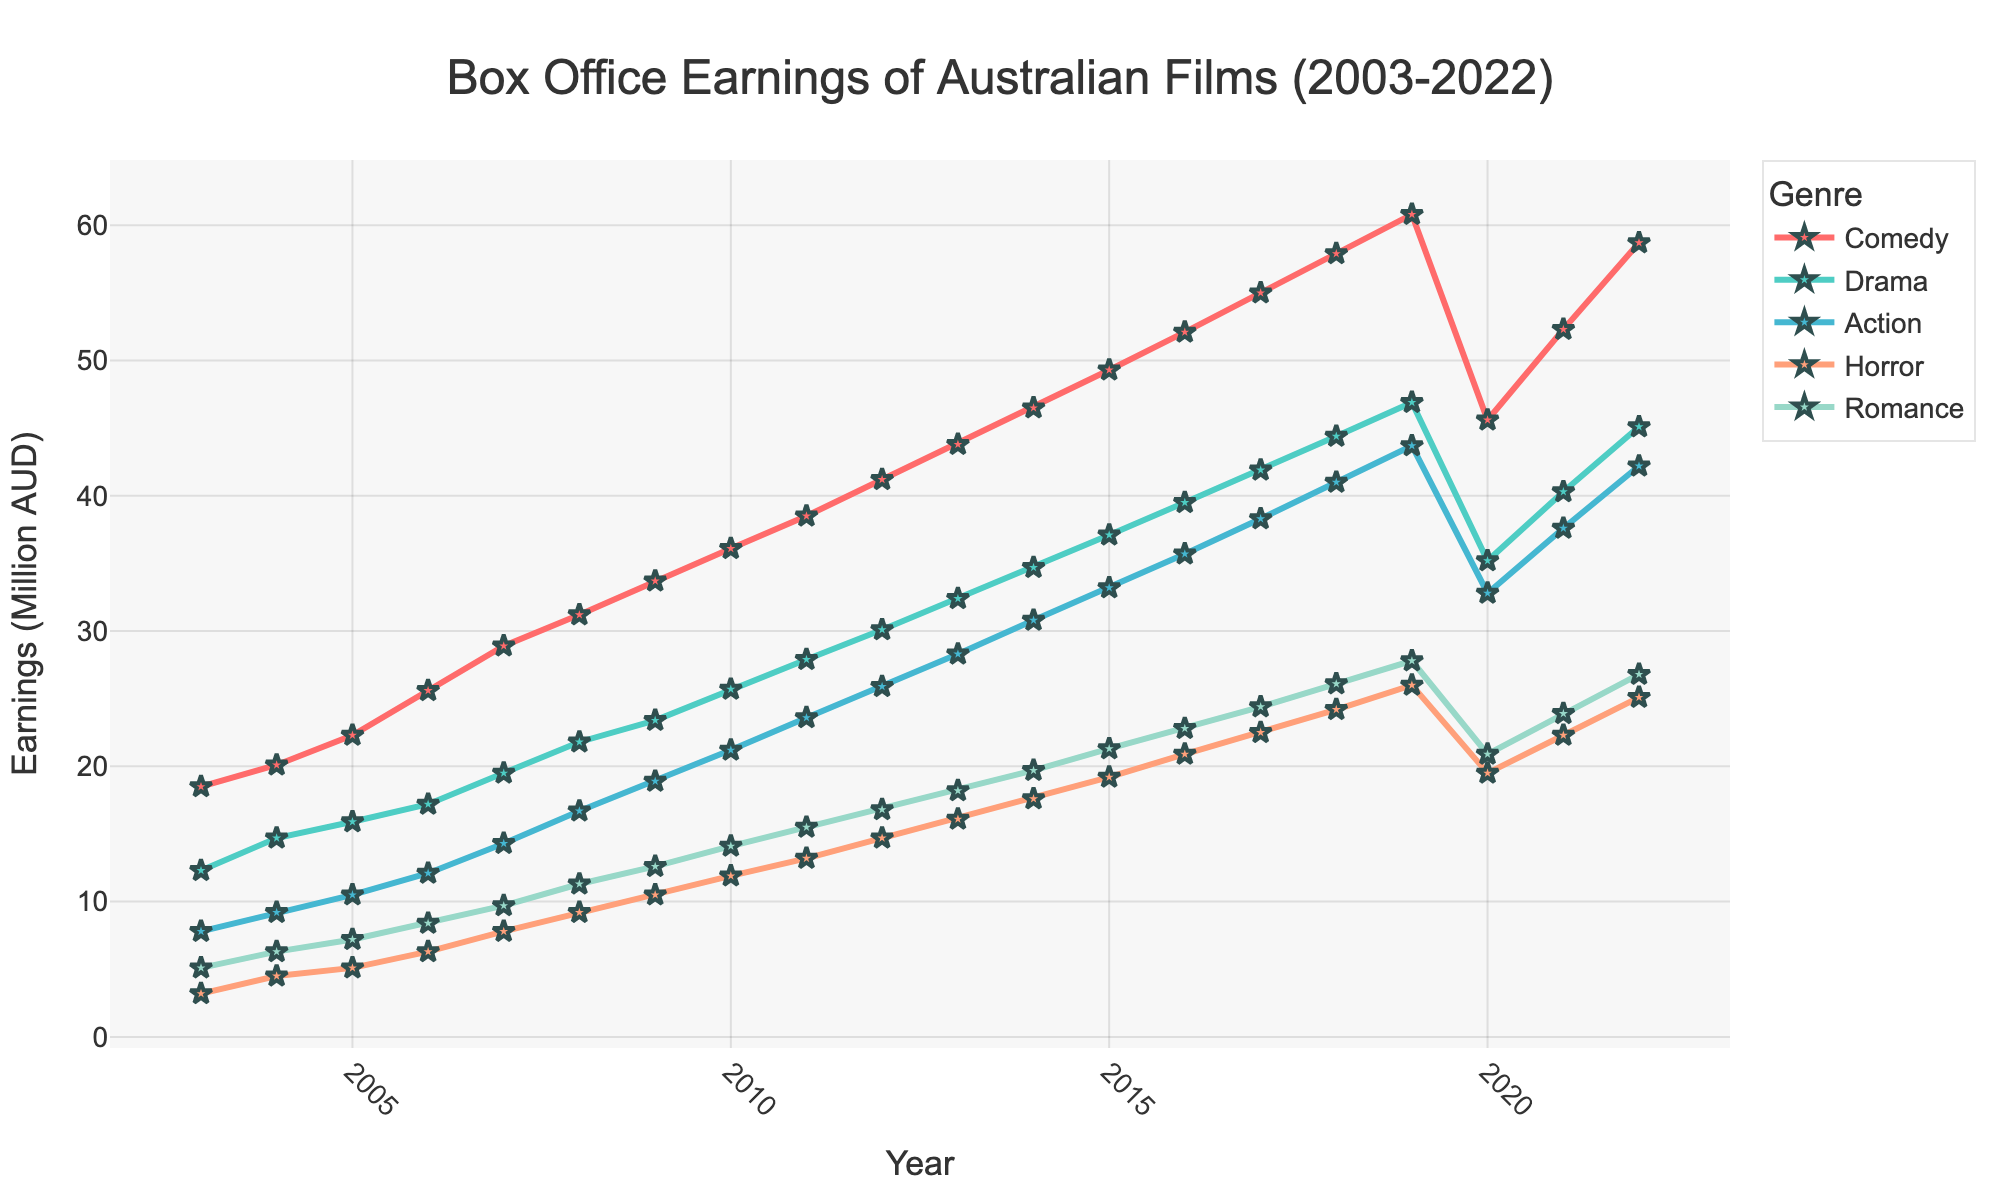How have box office earnings for Comedy films changed from 2003 to 2020? To find this, look at the Comedy line on the chart from 2003 to 2020. The earnings rise from 18.5 million AUD in 2003 to 60.8 million AUD in 2019, followed by a drop to 45.6 million AUD in 2020.
Answer: They increased from 18.5 million AUD to 60.8 million AUD then decreased to 45.6 million AUD In which year did Drama films surpass 30 million AUD in box office earnings? Find the point on the Drama line where the earnings first exceed 30 million AUD. This occurs in the year 2012, where Drama earns 30.1 million AUD.
Answer: 2012 What is the difference between Action and Horror film earnings in 2015? Identify the 2015 data points for both Action and Horror. Action films earned 33.2 million AUD, while Horror films earned 19.2 million AUD. Subtract Horror from Action: 33.2 - 19.2 = 14
Answer: 14 million AUD Which genre saw the most significant decline in earnings from 2019 to 2020? Compare the slope of each genre's line from 2019 to 2020. Comedy shows the largest drop from 60.8 million AUD to 45.6 million AUD, a decline of 15.2 million AUD.
Answer: Comedy What were the total box office earnings for Horror films over the span of 5 years from 2010 to 2014? Sum the Horror earnings from 2010 to 2014: 11.9 + 13.2 + 14.7 + 16.1 + 17.6 = 73.5 million AUD.
Answer: 73.5 million AUD Which genre had the highest box office earnings in 2018? Observe the chart at the year 2018 to see which line is the highest. Comedy has the highest earnings at 57.9 million AUD.
Answer: Comedy By what percentage did Romance film earnings grow from 2017 to 2018? Note the Romance earnings for 2017 and 2018: 24.4 million AUD and 26.1 million AUD, respectively. Calculate the percentage increase: ((26.1 - 24.4) / 24.4) * 100 ≈ 6.97%.
Answer: Approximately 6.97% During which period did Action films experience the most consistent growth? Look for the portion of the Action line that steadily rises without significant drops. The period from 2006 to 2019 shows consistent growth.
Answer: 2006 to 2019 Which two genres had almost equal earnings in 2020? Compare the data points for 2020. Action and Romance both have earnings close to each other, with Action at 32.8 million AUD and Romance at 20.9 million AUD.
Answer: Action and Romance Was there any genre whose earnings consistently increased every year without decline? Analyze each genre's line for any dips. Drama consistently increases every year without any decline from 2003 to 2019.
Answer: Drama 